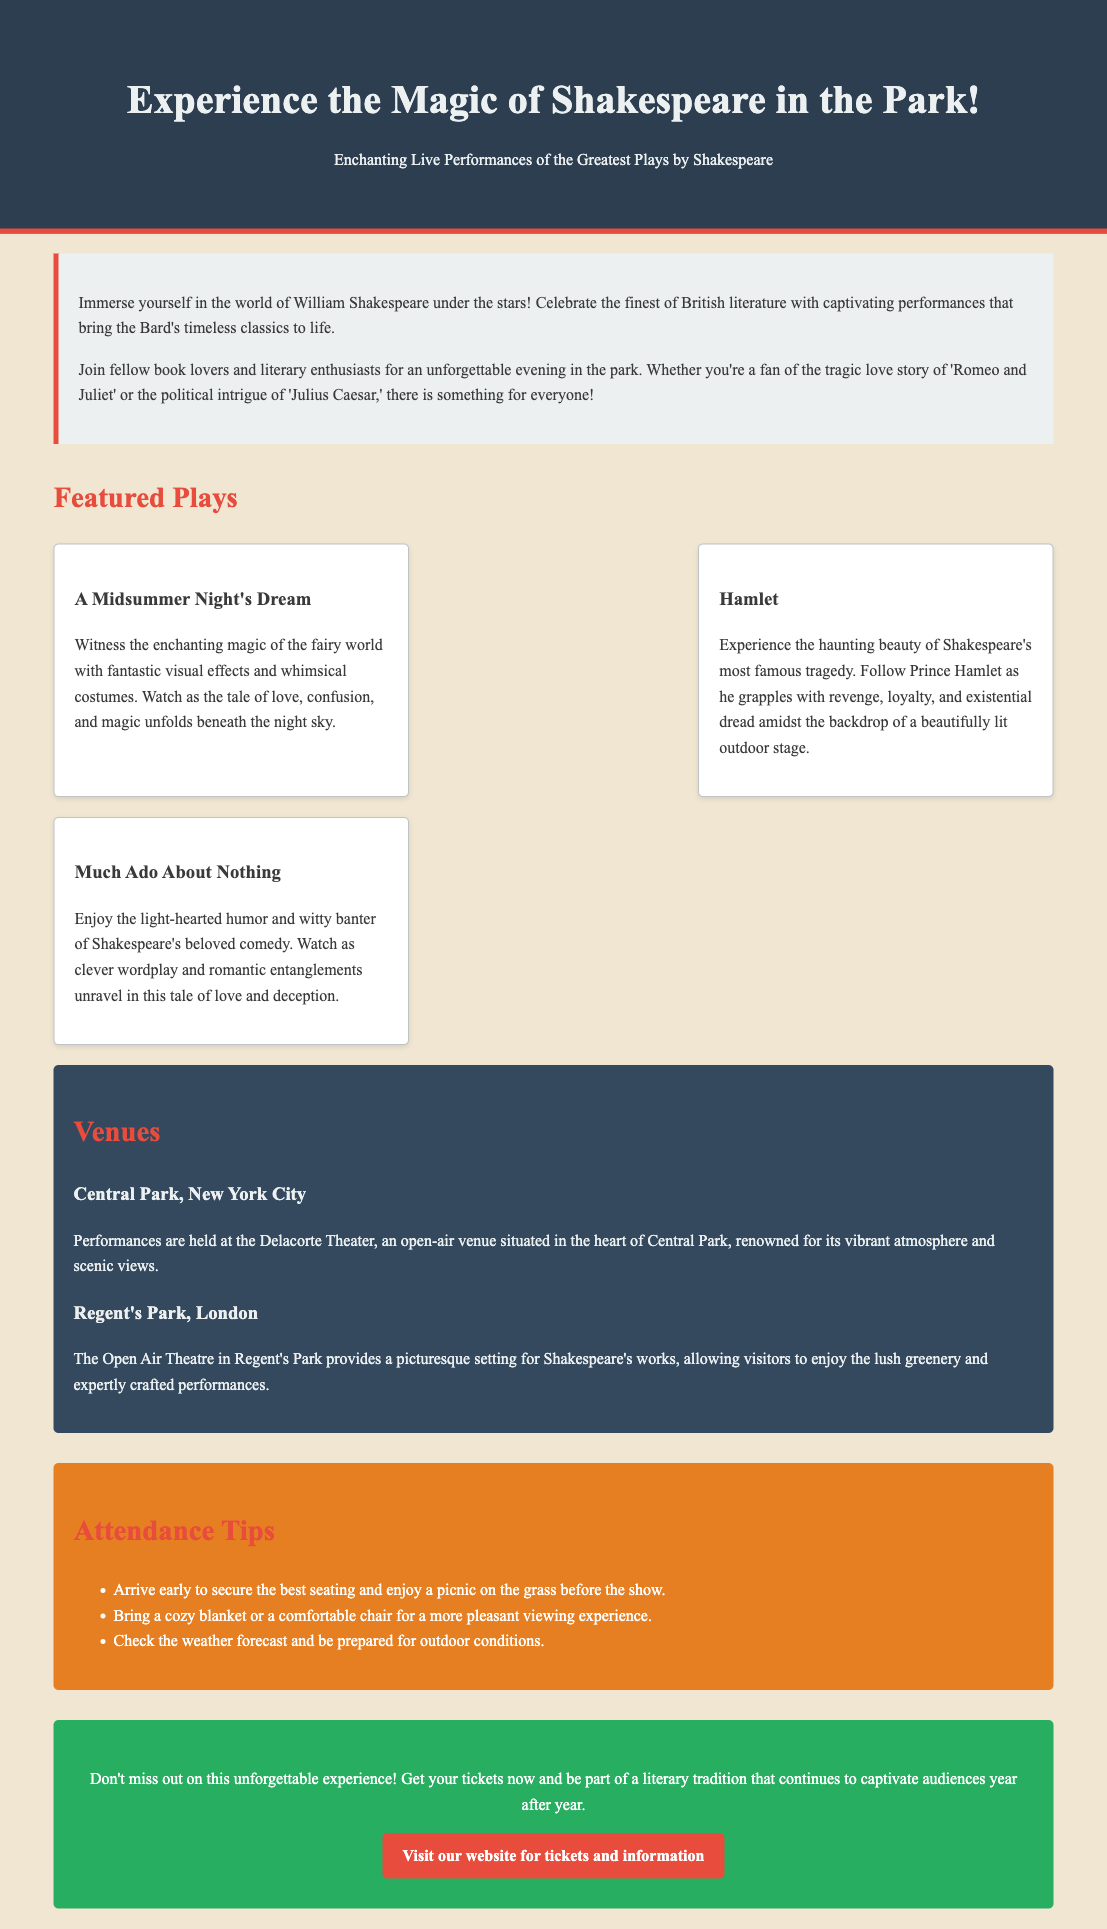What are the featured plays? The document lists three featured plays: A Midsummer Night's Dream, Hamlet, and Much Ado About Nothing.
Answer: A Midsummer Night's Dream, Hamlet, Much Ado About Nothing What is the venue in New York City? The document specifies that performances are held at the Delacorte Theater in Central Park, New York City.
Answer: Delacorte Theater What type of performance is 'Hamlet'? The document describes 'Hamlet' as Shakespeare's most famous tragedy.
Answer: Tragedy What should attendees bring for a better experience? The document suggests bringing a cozy blanket or a comfortable chair for a more pleasant viewing experience.
Answer: Blanket or chair What is the background color of the document? The document states that the background color is #f0e6d2, which is described as a light color in the css properties.
Answer: #f0e6d2 What is the call-to-action in the advertisement? The document urges visitors not to miss out and to get their tickets now for the experience.
Answer: Get your tickets now What type of atmosphere is described for the Delacorte Theater? The document mentions that Delacorte Theater is renowned for its vibrant atmosphere and scenic views.
Answer: Vibrant atmosphere and scenic views What is the primary theme of the advertisement? The primary theme is celebrating British literature through live performances of Shakespeare's works.
Answer: Celebration of British literature 